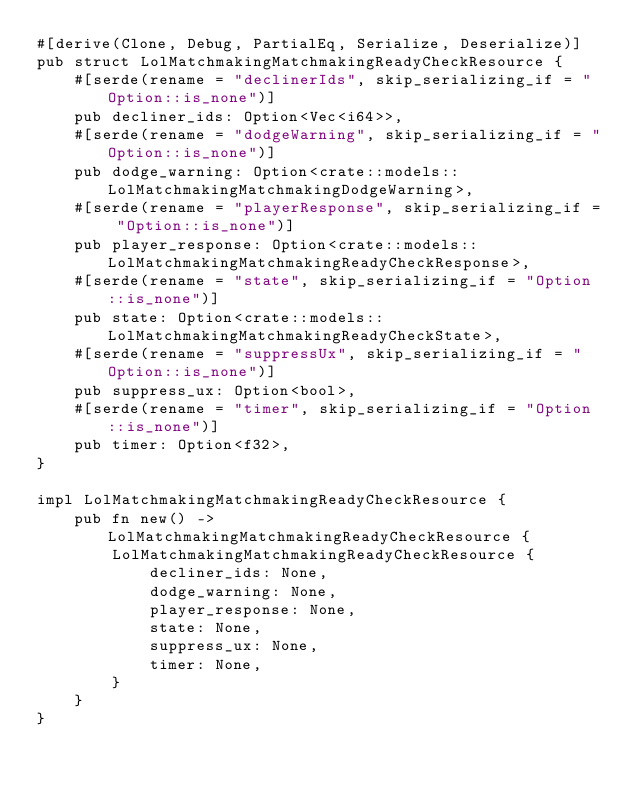Convert code to text. <code><loc_0><loc_0><loc_500><loc_500><_Rust_>#[derive(Clone, Debug, PartialEq, Serialize, Deserialize)]
pub struct LolMatchmakingMatchmakingReadyCheckResource {
    #[serde(rename = "declinerIds", skip_serializing_if = "Option::is_none")]
    pub decliner_ids: Option<Vec<i64>>,
    #[serde(rename = "dodgeWarning", skip_serializing_if = "Option::is_none")]
    pub dodge_warning: Option<crate::models::LolMatchmakingMatchmakingDodgeWarning>,
    #[serde(rename = "playerResponse", skip_serializing_if = "Option::is_none")]
    pub player_response: Option<crate::models::LolMatchmakingMatchmakingReadyCheckResponse>,
    #[serde(rename = "state", skip_serializing_if = "Option::is_none")]
    pub state: Option<crate::models::LolMatchmakingMatchmakingReadyCheckState>,
    #[serde(rename = "suppressUx", skip_serializing_if = "Option::is_none")]
    pub suppress_ux: Option<bool>,
    #[serde(rename = "timer", skip_serializing_if = "Option::is_none")]
    pub timer: Option<f32>,
}

impl LolMatchmakingMatchmakingReadyCheckResource {
    pub fn new() -> LolMatchmakingMatchmakingReadyCheckResource {
        LolMatchmakingMatchmakingReadyCheckResource {
            decliner_ids: None,
            dodge_warning: None,
            player_response: None,
            state: None,
            suppress_ux: None,
            timer: None,
        }
    }
}


</code> 